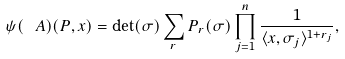<formula> <loc_0><loc_0><loc_500><loc_500>\psi ( \ A ) ( P , x ) = \det ( \sigma ) \sum _ { r } P _ { r } ( \sigma ) \prod _ { j = 1 } ^ { n } \frac { 1 } { \langle x , \sigma _ { j } \rangle ^ { 1 + r _ { j } } } ,</formula> 